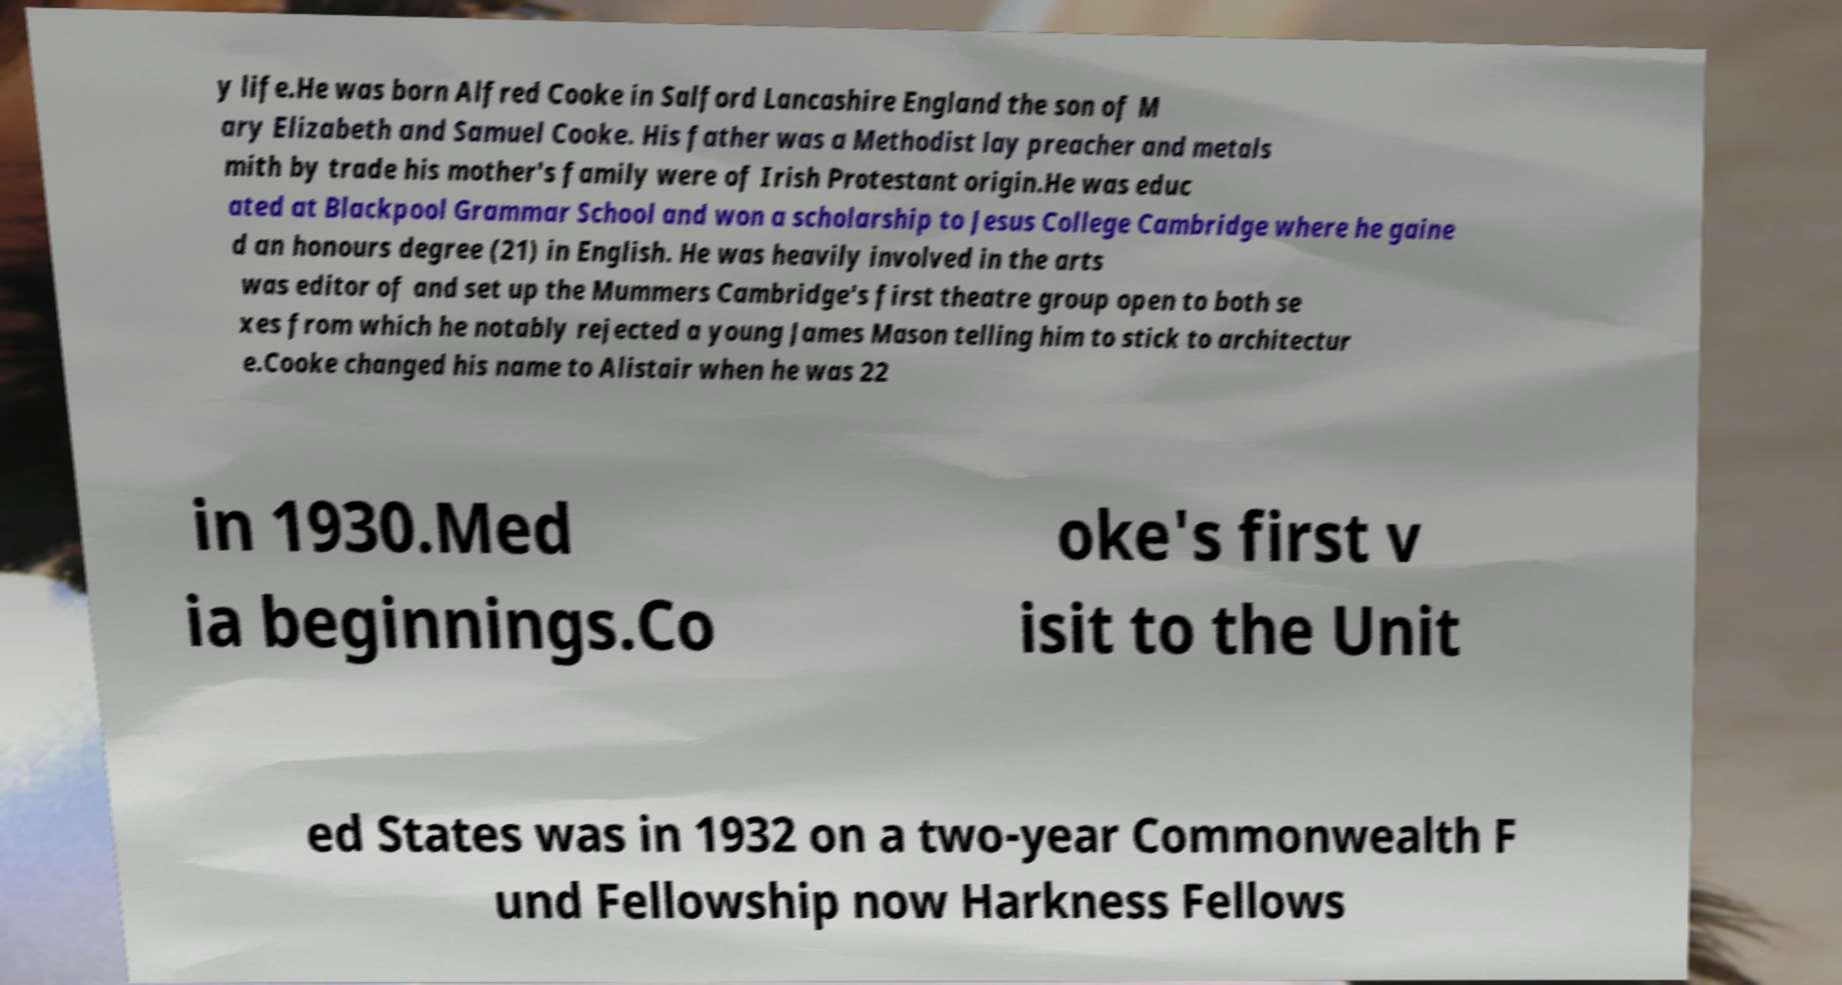I need the written content from this picture converted into text. Can you do that? y life.He was born Alfred Cooke in Salford Lancashire England the son of M ary Elizabeth and Samuel Cooke. His father was a Methodist lay preacher and metals mith by trade his mother's family were of Irish Protestant origin.He was educ ated at Blackpool Grammar School and won a scholarship to Jesus College Cambridge where he gaine d an honours degree (21) in English. He was heavily involved in the arts was editor of and set up the Mummers Cambridge's first theatre group open to both se xes from which he notably rejected a young James Mason telling him to stick to architectur e.Cooke changed his name to Alistair when he was 22 in 1930.Med ia beginnings.Co oke's first v isit to the Unit ed States was in 1932 on a two-year Commonwealth F und Fellowship now Harkness Fellows 